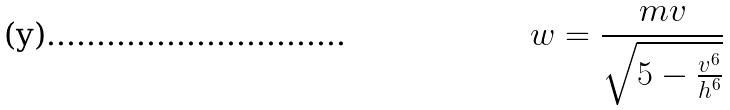<formula> <loc_0><loc_0><loc_500><loc_500>w = \frac { m v } { \sqrt { 5 - \frac { v ^ { 6 } } { h ^ { 6 } } } }</formula> 